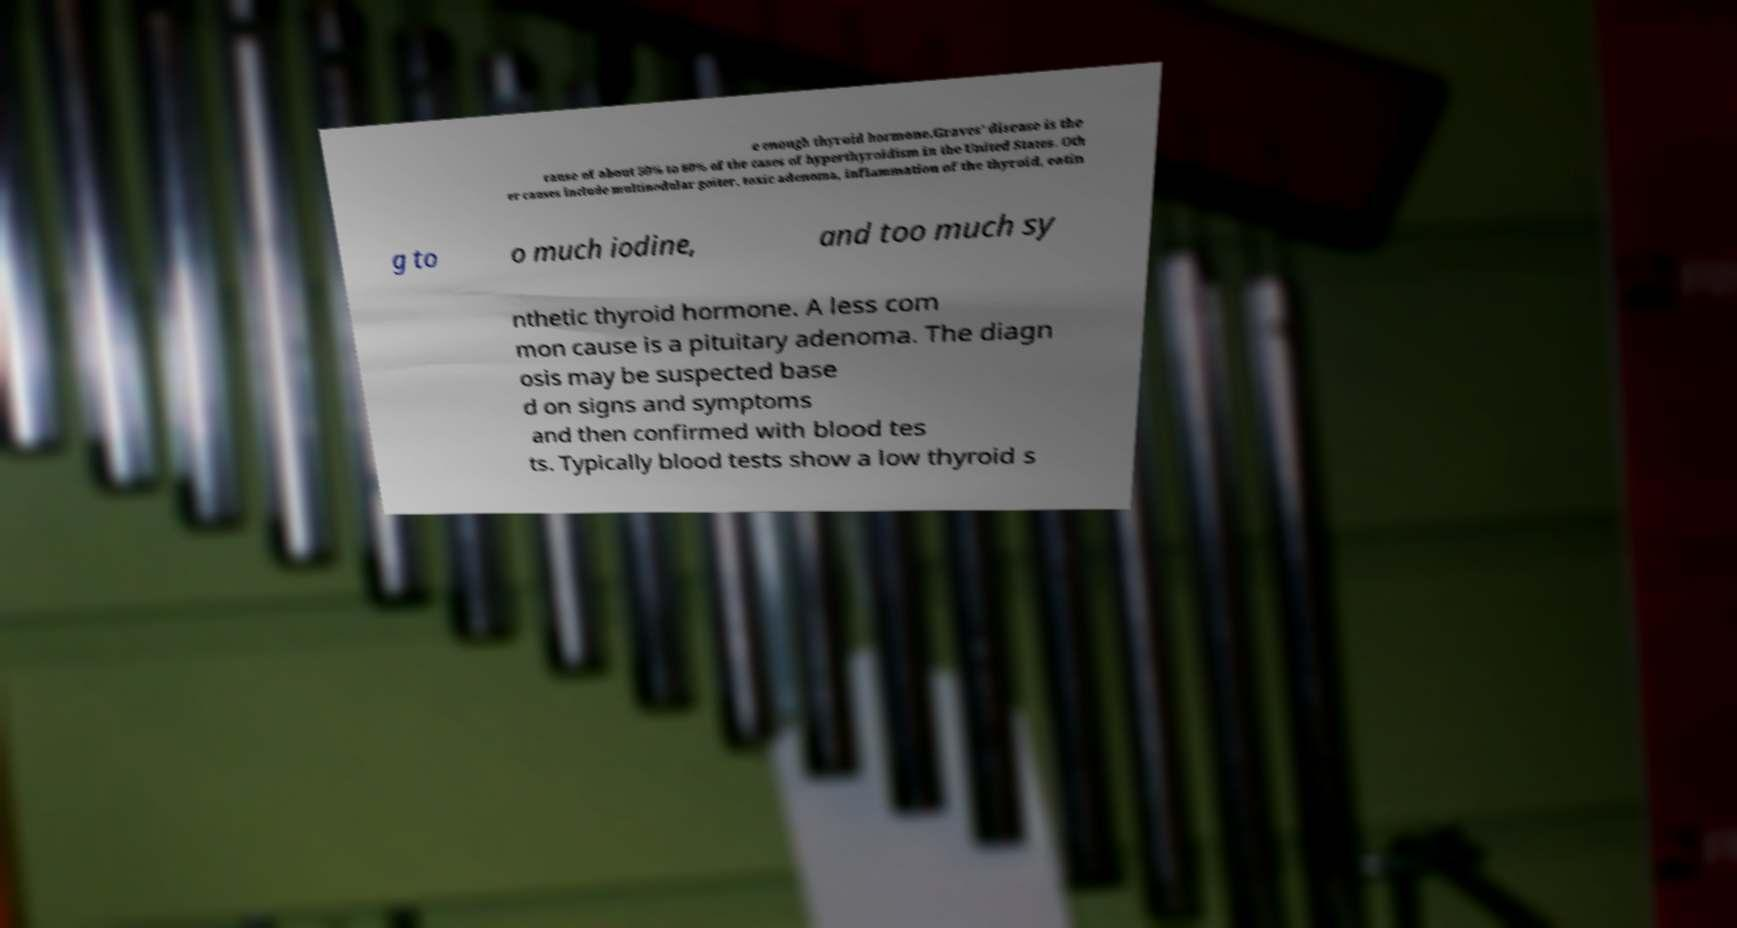Could you assist in decoding the text presented in this image and type it out clearly? e enough thyroid hormone.Graves' disease is the cause of about 50% to 80% of the cases of hyperthyroidism in the United States. Oth er causes include multinodular goiter, toxic adenoma, inflammation of the thyroid, eatin g to o much iodine, and too much sy nthetic thyroid hormone. A less com mon cause is a pituitary adenoma. The diagn osis may be suspected base d on signs and symptoms and then confirmed with blood tes ts. Typically blood tests show a low thyroid s 